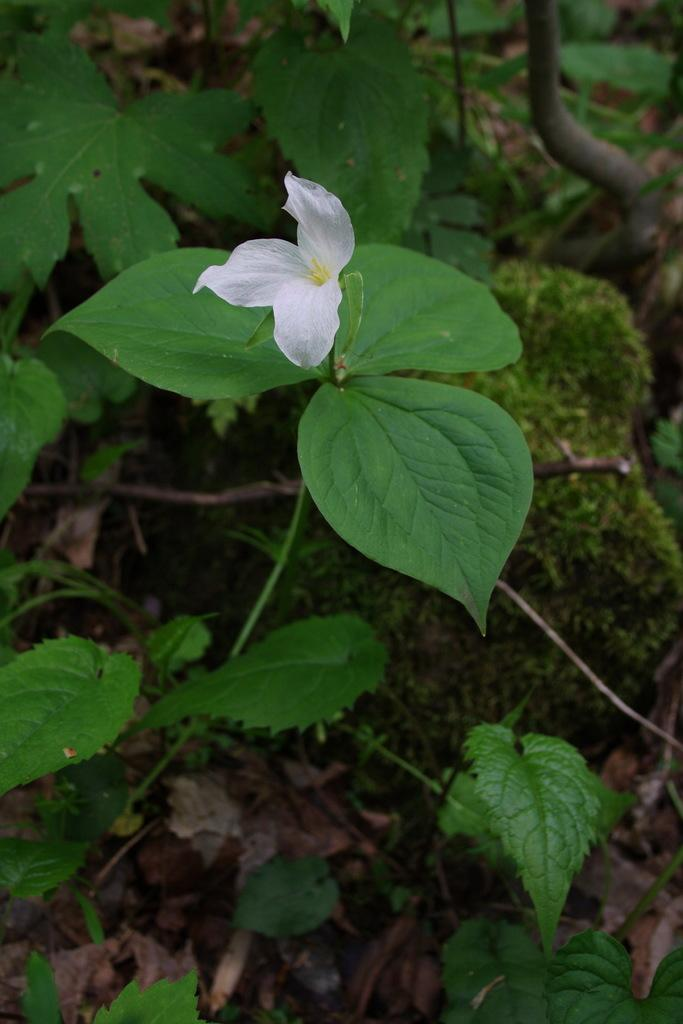What type of living organisms can be seen in the image? Plants and a flower are visible in the image. Can you describe the flower in the image? The flower is a part of the plant in the image. How many cherries are hanging from the flower in the image? There are no cherries present in the image; it features plants and a flower. Can you describe the interaction between the stranger and the flower in the image? There is no stranger present in the image, only plants and a flower. 